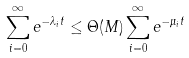<formula> <loc_0><loc_0><loc_500><loc_500>\sum _ { i = 0 } ^ { \infty } { e ^ { - \lambda _ { i } t } } \leq \Theta ( M ) \sum _ { i = 0 } ^ { \infty } { e ^ { - \mu _ { i } t } }</formula> 